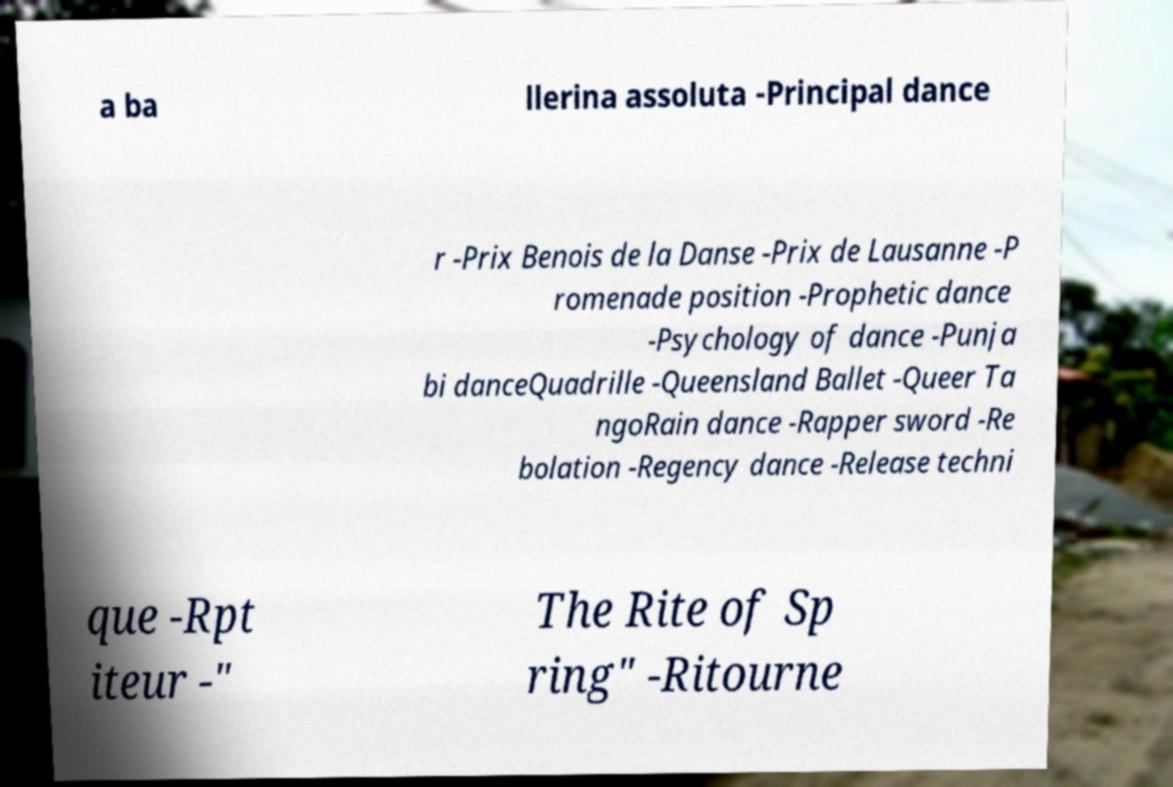There's text embedded in this image that I need extracted. Can you transcribe it verbatim? a ba llerina assoluta -Principal dance r -Prix Benois de la Danse -Prix de Lausanne -P romenade position -Prophetic dance -Psychology of dance -Punja bi danceQuadrille -Queensland Ballet -Queer Ta ngoRain dance -Rapper sword -Re bolation -Regency dance -Release techni que -Rpt iteur -" The Rite of Sp ring" -Ritourne 